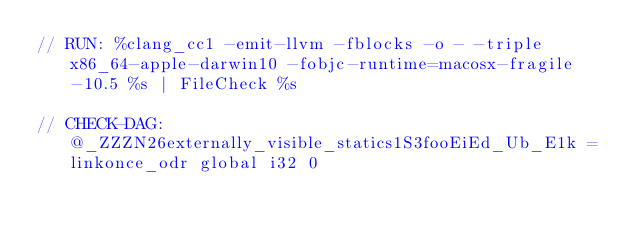<code> <loc_0><loc_0><loc_500><loc_500><_ObjectiveC_>// RUN: %clang_cc1 -emit-llvm -fblocks -o - -triple x86_64-apple-darwin10 -fobjc-runtime=macosx-fragile-10.5 %s | FileCheck %s

// CHECK-DAG: @_ZZZN26externally_visible_statics1S3fooEiEd_Ub_E1k = linkonce_odr global i32 0</code> 